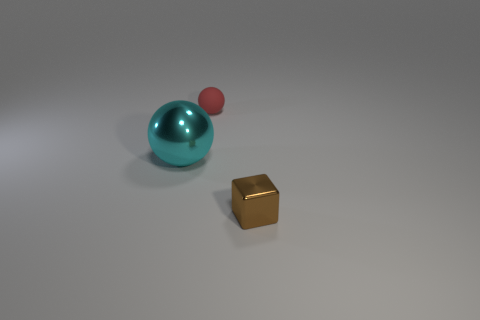The object that is both behind the small brown metallic thing and in front of the tiny sphere has what shape?
Your response must be concise. Sphere. What color is the other thing that is the same shape as the cyan object?
Provide a succinct answer. Red. How many objects are metallic objects that are behind the small brown block or things that are to the right of the cyan metallic sphere?
Your response must be concise. 3. The tiny matte thing is what shape?
Ensure brevity in your answer.  Sphere. How many cyan objects are made of the same material as the tiny brown block?
Provide a short and direct response. 1. The matte ball has what color?
Provide a succinct answer. Red. What is the color of the rubber object that is the same size as the metallic block?
Offer a terse response. Red. Do the object left of the tiny red matte ball and the tiny thing that is behind the cyan metal ball have the same shape?
Your response must be concise. Yes. What number of other things are there of the same size as the cube?
Your answer should be compact. 1. There is a shiny sphere; is it the same color as the metallic object that is right of the tiny sphere?
Provide a succinct answer. No. 